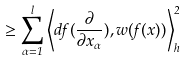Convert formula to latex. <formula><loc_0><loc_0><loc_500><loc_500>\geq \sum _ { \alpha = 1 } ^ { l } \left \langle d f ( \frac { \partial } { \partial x _ { \alpha } } ) , w ( f ( x ) ) \right \rangle _ { h } ^ { 2 }</formula> 